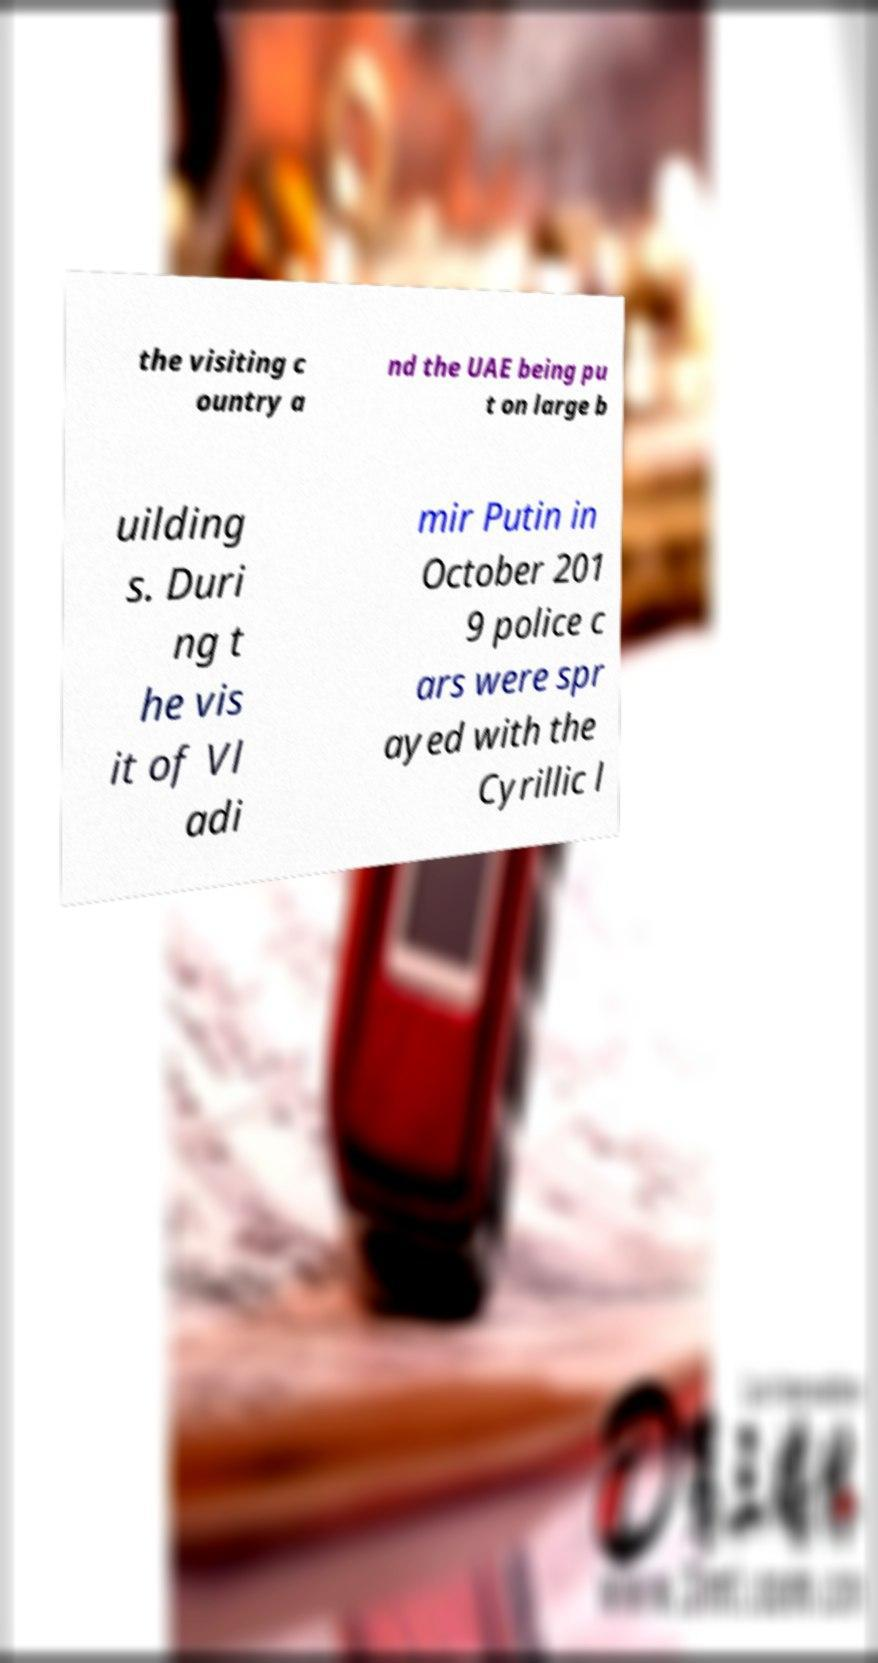Could you assist in decoding the text presented in this image and type it out clearly? the visiting c ountry a nd the UAE being pu t on large b uilding s. Duri ng t he vis it of Vl adi mir Putin in October 201 9 police c ars were spr ayed with the Cyrillic l 